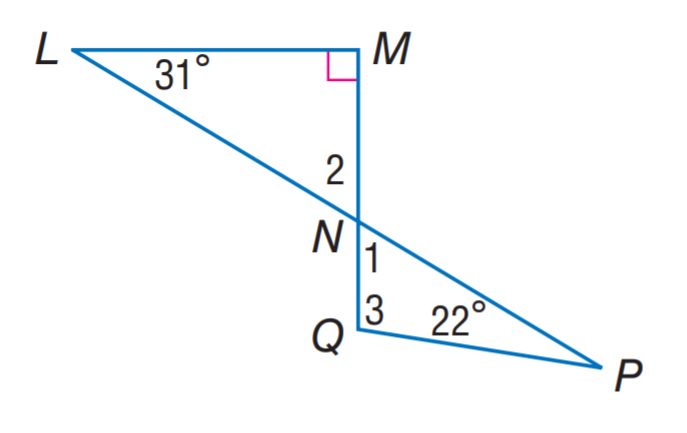Answer the mathemtical geometry problem and directly provide the correct option letter.
Question: Find m \angle 3.
Choices: A: 59 B: 81 C: 99 D: 102 C 